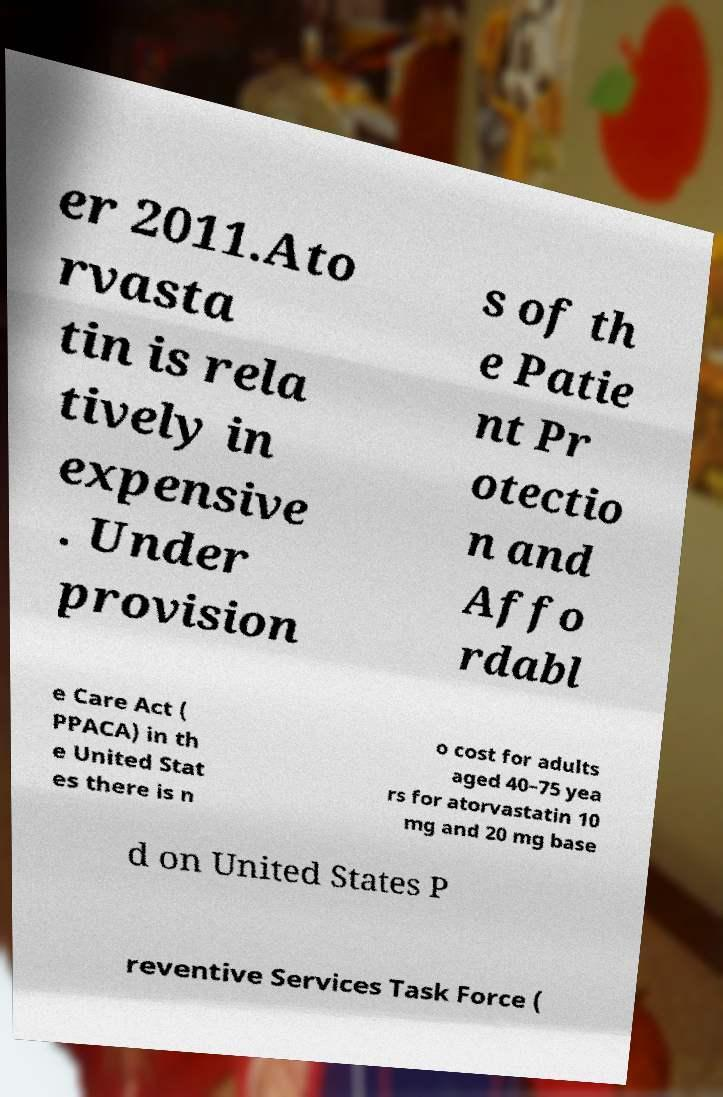Please read and relay the text visible in this image. What does it say? er 2011.Ato rvasta tin is rela tively in expensive . Under provision s of th e Patie nt Pr otectio n and Affo rdabl e Care Act ( PPACA) in th e United Stat es there is n o cost for adults aged 40–75 yea rs for atorvastatin 10 mg and 20 mg base d on United States P reventive Services Task Force ( 